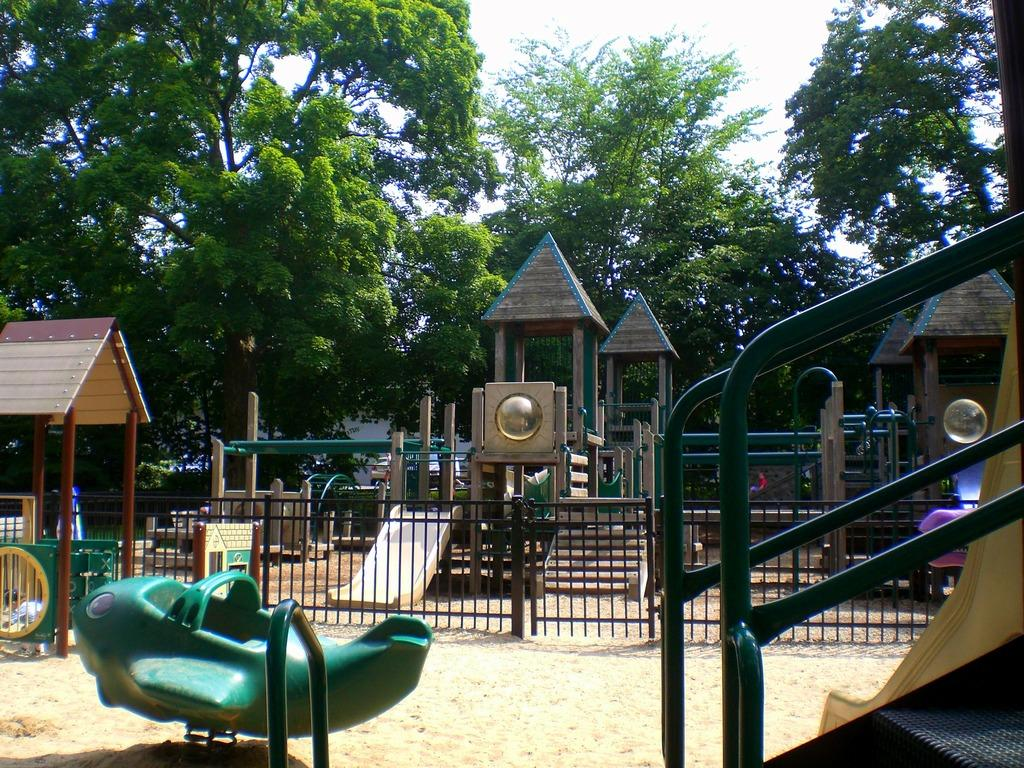What type of natural elements can be seen in the image? There are trees in the image. What type of recreational equipment for children is present in the image? There are equipment for kids, such as slides, in the image. What is the minister doing in the image? There is no minister present in the image. What is the general feeling or emotion conveyed by the image? The image does not convey a specific feeling or emotion, such as disgust. 